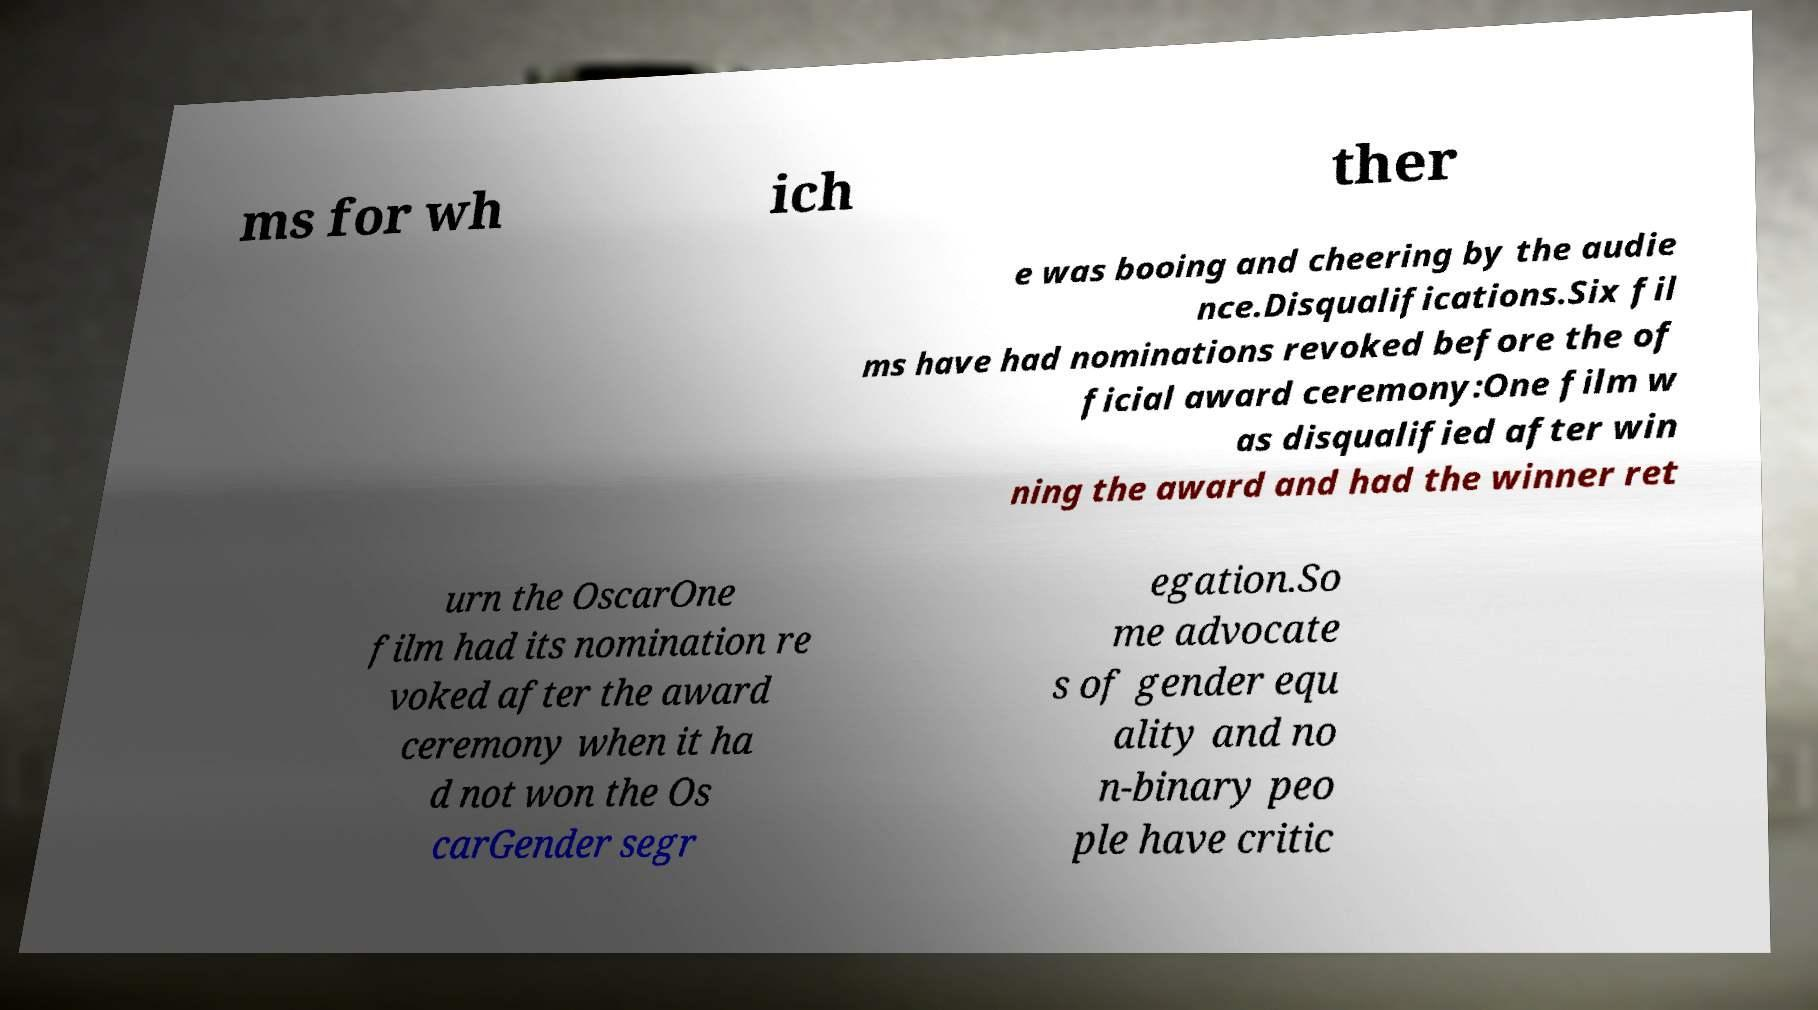I need the written content from this picture converted into text. Can you do that? ms for wh ich ther e was booing and cheering by the audie nce.Disqualifications.Six fil ms have had nominations revoked before the of ficial award ceremony:One film w as disqualified after win ning the award and had the winner ret urn the OscarOne film had its nomination re voked after the award ceremony when it ha d not won the Os carGender segr egation.So me advocate s of gender equ ality and no n-binary peo ple have critic 